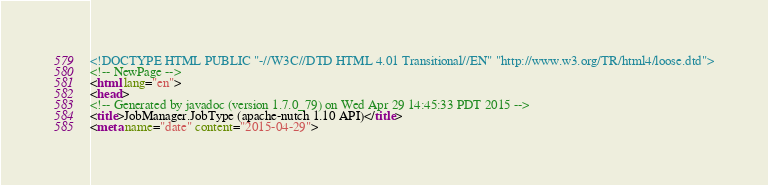Convert code to text. <code><loc_0><loc_0><loc_500><loc_500><_HTML_><!DOCTYPE HTML PUBLIC "-//W3C//DTD HTML 4.01 Transitional//EN" "http://www.w3.org/TR/html4/loose.dtd">
<!-- NewPage -->
<html lang="en">
<head>
<!-- Generated by javadoc (version 1.7.0_79) on Wed Apr 29 14:45:33 PDT 2015 -->
<title>JobManager.JobType (apache-nutch 1.10 API)</title>
<meta name="date" content="2015-04-29"></code> 